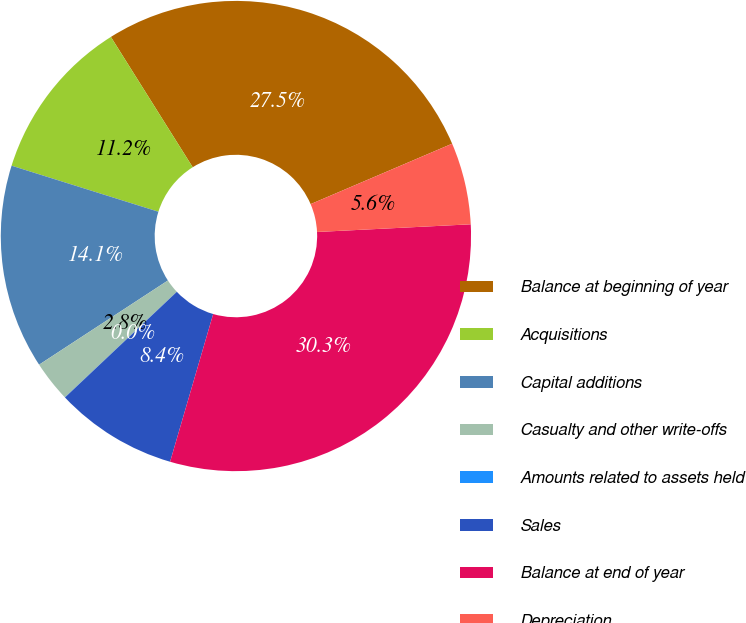Convert chart. <chart><loc_0><loc_0><loc_500><loc_500><pie_chart><fcel>Balance at beginning of year<fcel>Acquisitions<fcel>Capital additions<fcel>Casualty and other write-offs<fcel>Amounts related to assets held<fcel>Sales<fcel>Balance at end of year<fcel>Depreciation<nl><fcel>27.5%<fcel>11.24%<fcel>14.05%<fcel>2.82%<fcel>0.01%<fcel>8.44%<fcel>30.31%<fcel>5.63%<nl></chart> 